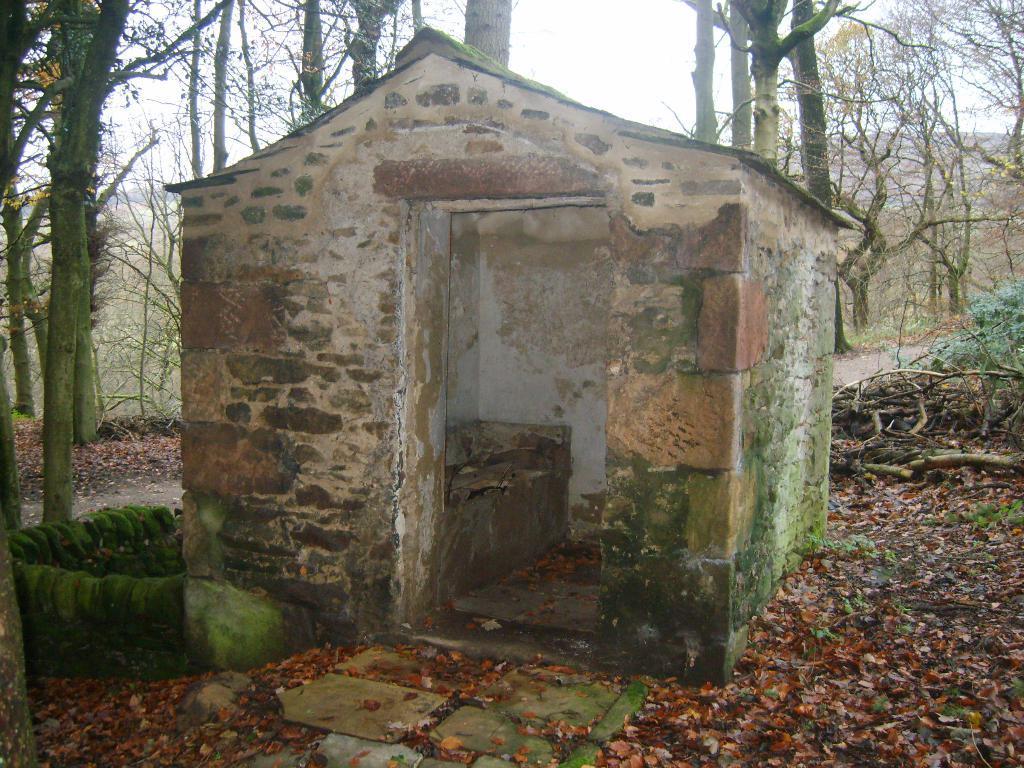Can you describe this image briefly? In this image there is an old house and some algae on the house, around the house there are trees, plants and some dry leaves on the surface. 